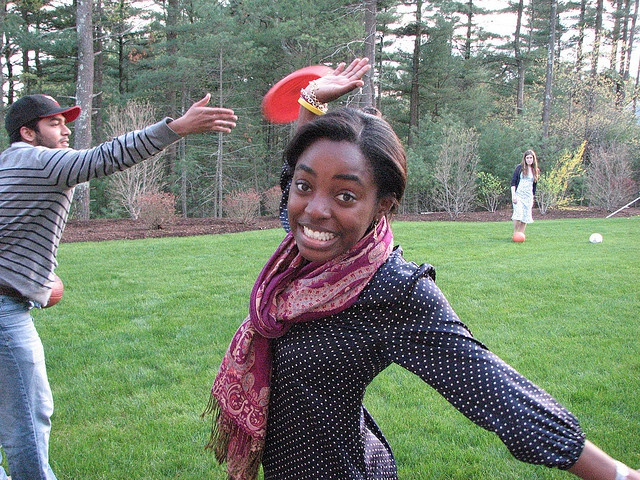Describe the objects in this image and their specific colors. I can see people in teal, black, gray, brown, and maroon tones, people in teal, gray, lavender, and darkgray tones, frisbee in teal, salmon, red, and pink tones, people in teal, white, darkgray, and gray tones, and sports ball in teal, pink, lightpink, and brown tones in this image. 